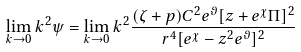Convert formula to latex. <formula><loc_0><loc_0><loc_500><loc_500>\lim _ { k \rightarrow 0 } k ^ { 2 } \psi = \lim _ { k \rightarrow 0 } k ^ { 2 } \frac { ( \zeta + p ) C ^ { 2 } e ^ { \vartheta } [ z + e ^ { \chi } \Pi ] ^ { 2 } } { r ^ { 4 } [ e ^ { \chi } - z ^ { 2 } e ^ { \vartheta } ] ^ { 2 } }</formula> 